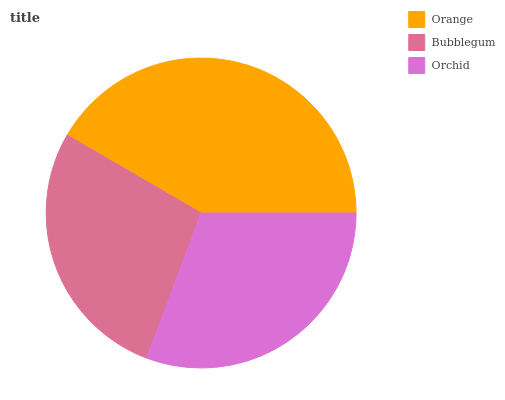Is Bubblegum the minimum?
Answer yes or no. Yes. Is Orange the maximum?
Answer yes or no. Yes. Is Orchid the minimum?
Answer yes or no. No. Is Orchid the maximum?
Answer yes or no. No. Is Orchid greater than Bubblegum?
Answer yes or no. Yes. Is Bubblegum less than Orchid?
Answer yes or no. Yes. Is Bubblegum greater than Orchid?
Answer yes or no. No. Is Orchid less than Bubblegum?
Answer yes or no. No. Is Orchid the high median?
Answer yes or no. Yes. Is Orchid the low median?
Answer yes or no. Yes. Is Bubblegum the high median?
Answer yes or no. No. Is Bubblegum the low median?
Answer yes or no. No. 